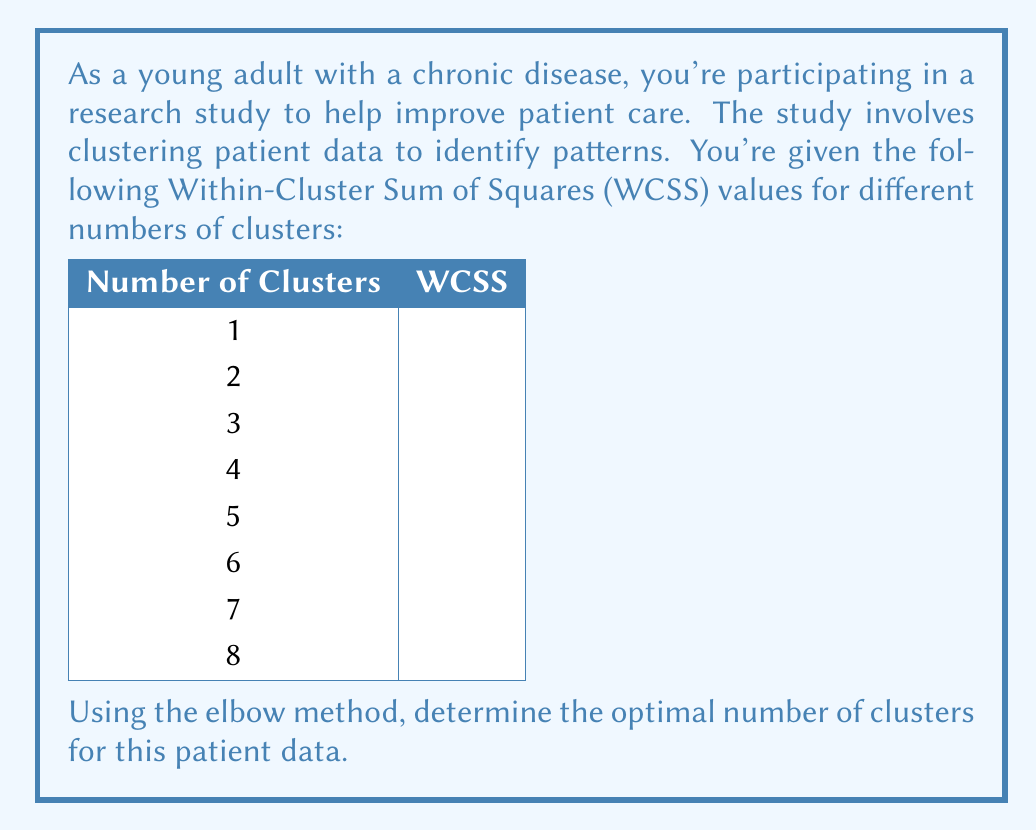Could you help me with this problem? To determine the optimal number of clusters using the elbow method, we need to follow these steps:

1. Plot the WCSS values against the number of clusters.
2. Look for the "elbow" point in the graph, where the rate of decrease in WCSS slows down significantly.

Let's visualize the data:

[asy]
import graph;
size(200,150);
real[] x = {1,2,3,4,5,6,7,8};
real[] y = {1000,800,600,450,400,380,370,365};
draw(graph(x,y),red+0.8bp);
for(int i=0; i<8; ++i) {
  dot((x[i],y[i]),blue);
}
xaxis("Number of Clusters",0,9,Arrow);
yaxis("WCSS",0,1100,Arrow);
label("Elbow point",(4,450),NE);
draw((4,450)--(4,450),ellipse,red+1bp);
[/asy]

Analyzing the graph:

1. We see a sharp decrease in WCSS from 1 to 4 clusters.
2. After 4 clusters, the rate of decrease slows down significantly.
3. The point at 4 clusters forms an "elbow" in the graph.

This elbow point represents the optimal number of clusters because:
- It balances between minimizing within-cluster variation and avoiding overfitting.
- Adding more clusters after this point provides diminishing returns in terms of explaining the data's variance.

In this case, the elbow occurs at 4 clusters, which suggests that dividing the patient data into 4 groups would provide the most meaningful insights without unnecessary complexity.
Answer: The optimal number of clusters for the patient data using the elbow method is 4. 